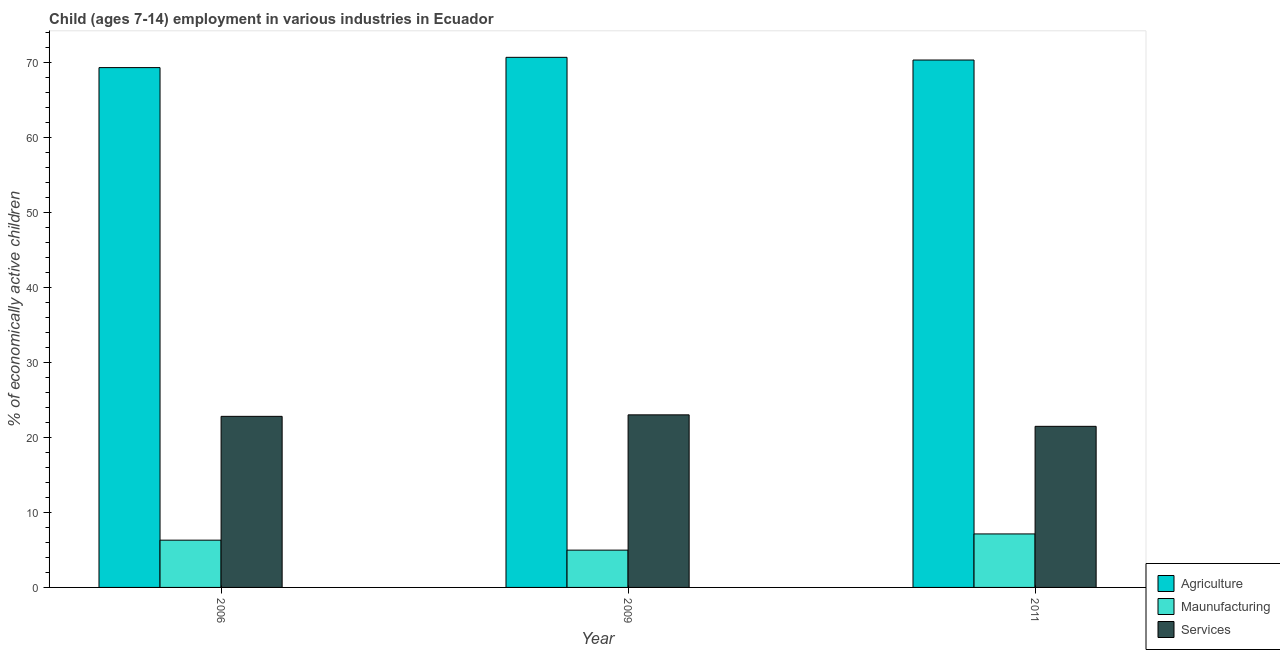How many different coloured bars are there?
Offer a very short reply. 3. Are the number of bars per tick equal to the number of legend labels?
Your answer should be compact. Yes. Are the number of bars on each tick of the X-axis equal?
Provide a succinct answer. Yes. How many bars are there on the 2nd tick from the left?
Your answer should be very brief. 3. In how many cases, is the number of bars for a given year not equal to the number of legend labels?
Your response must be concise. 0. Across all years, what is the maximum percentage of economically active children in agriculture?
Ensure brevity in your answer.  70.65. Across all years, what is the minimum percentage of economically active children in manufacturing?
Ensure brevity in your answer.  4.97. What is the total percentage of economically active children in agriculture in the graph?
Your response must be concise. 210.22. What is the difference between the percentage of economically active children in services in 2006 and that in 2011?
Your answer should be compact. 1.33. What is the difference between the percentage of economically active children in agriculture in 2011 and the percentage of economically active children in manufacturing in 2009?
Your answer should be very brief. -0.36. What is the average percentage of economically active children in agriculture per year?
Ensure brevity in your answer.  70.07. In the year 2011, what is the difference between the percentage of economically active children in agriculture and percentage of economically active children in services?
Keep it short and to the point. 0. What is the ratio of the percentage of economically active children in agriculture in 2006 to that in 2009?
Your answer should be compact. 0.98. What is the difference between the highest and the second highest percentage of economically active children in agriculture?
Your answer should be compact. 0.36. What is the difference between the highest and the lowest percentage of economically active children in agriculture?
Make the answer very short. 1.37. What does the 3rd bar from the left in 2006 represents?
Offer a terse response. Services. What does the 2nd bar from the right in 2011 represents?
Make the answer very short. Maunufacturing. Does the graph contain grids?
Keep it short and to the point. No. How are the legend labels stacked?
Offer a very short reply. Vertical. What is the title of the graph?
Offer a very short reply. Child (ages 7-14) employment in various industries in Ecuador. Does "Domestic" appear as one of the legend labels in the graph?
Your answer should be very brief. No. What is the label or title of the Y-axis?
Ensure brevity in your answer.  % of economically active children. What is the % of economically active children of Agriculture in 2006?
Your response must be concise. 69.28. What is the % of economically active children of Services in 2006?
Provide a short and direct response. 22.8. What is the % of economically active children in Agriculture in 2009?
Offer a terse response. 70.65. What is the % of economically active children of Maunufacturing in 2009?
Keep it short and to the point. 4.97. What is the % of economically active children in Agriculture in 2011?
Offer a very short reply. 70.29. What is the % of economically active children of Maunufacturing in 2011?
Your answer should be compact. 7.13. What is the % of economically active children of Services in 2011?
Your answer should be very brief. 21.47. Across all years, what is the maximum % of economically active children in Agriculture?
Your response must be concise. 70.65. Across all years, what is the maximum % of economically active children in Maunufacturing?
Offer a very short reply. 7.13. Across all years, what is the maximum % of economically active children in Services?
Provide a short and direct response. 23. Across all years, what is the minimum % of economically active children of Agriculture?
Offer a terse response. 69.28. Across all years, what is the minimum % of economically active children of Maunufacturing?
Your answer should be compact. 4.97. Across all years, what is the minimum % of economically active children of Services?
Offer a very short reply. 21.47. What is the total % of economically active children in Agriculture in the graph?
Your answer should be compact. 210.22. What is the total % of economically active children of Services in the graph?
Offer a very short reply. 67.27. What is the difference between the % of economically active children of Agriculture in 2006 and that in 2009?
Offer a very short reply. -1.37. What is the difference between the % of economically active children in Maunufacturing in 2006 and that in 2009?
Your answer should be very brief. 1.33. What is the difference between the % of economically active children in Agriculture in 2006 and that in 2011?
Provide a succinct answer. -1.01. What is the difference between the % of economically active children in Maunufacturing in 2006 and that in 2011?
Make the answer very short. -0.83. What is the difference between the % of economically active children in Services in 2006 and that in 2011?
Provide a succinct answer. 1.33. What is the difference between the % of economically active children of Agriculture in 2009 and that in 2011?
Provide a succinct answer. 0.36. What is the difference between the % of economically active children of Maunufacturing in 2009 and that in 2011?
Your answer should be very brief. -2.16. What is the difference between the % of economically active children in Services in 2009 and that in 2011?
Your response must be concise. 1.53. What is the difference between the % of economically active children in Agriculture in 2006 and the % of economically active children in Maunufacturing in 2009?
Provide a short and direct response. 64.31. What is the difference between the % of economically active children in Agriculture in 2006 and the % of economically active children in Services in 2009?
Ensure brevity in your answer.  46.28. What is the difference between the % of economically active children in Maunufacturing in 2006 and the % of economically active children in Services in 2009?
Provide a short and direct response. -16.7. What is the difference between the % of economically active children of Agriculture in 2006 and the % of economically active children of Maunufacturing in 2011?
Offer a terse response. 62.15. What is the difference between the % of economically active children of Agriculture in 2006 and the % of economically active children of Services in 2011?
Provide a succinct answer. 47.81. What is the difference between the % of economically active children of Maunufacturing in 2006 and the % of economically active children of Services in 2011?
Your answer should be very brief. -15.17. What is the difference between the % of economically active children in Agriculture in 2009 and the % of economically active children in Maunufacturing in 2011?
Keep it short and to the point. 63.52. What is the difference between the % of economically active children in Agriculture in 2009 and the % of economically active children in Services in 2011?
Your response must be concise. 49.18. What is the difference between the % of economically active children in Maunufacturing in 2009 and the % of economically active children in Services in 2011?
Offer a terse response. -16.5. What is the average % of economically active children of Agriculture per year?
Give a very brief answer. 70.07. What is the average % of economically active children of Maunufacturing per year?
Your response must be concise. 6.13. What is the average % of economically active children of Services per year?
Offer a terse response. 22.42. In the year 2006, what is the difference between the % of economically active children of Agriculture and % of economically active children of Maunufacturing?
Provide a short and direct response. 62.98. In the year 2006, what is the difference between the % of economically active children in Agriculture and % of economically active children in Services?
Keep it short and to the point. 46.48. In the year 2006, what is the difference between the % of economically active children in Maunufacturing and % of economically active children in Services?
Provide a succinct answer. -16.5. In the year 2009, what is the difference between the % of economically active children in Agriculture and % of economically active children in Maunufacturing?
Provide a short and direct response. 65.68. In the year 2009, what is the difference between the % of economically active children of Agriculture and % of economically active children of Services?
Offer a very short reply. 47.65. In the year 2009, what is the difference between the % of economically active children of Maunufacturing and % of economically active children of Services?
Offer a very short reply. -18.03. In the year 2011, what is the difference between the % of economically active children of Agriculture and % of economically active children of Maunufacturing?
Provide a succinct answer. 63.16. In the year 2011, what is the difference between the % of economically active children in Agriculture and % of economically active children in Services?
Your answer should be compact. 48.82. In the year 2011, what is the difference between the % of economically active children in Maunufacturing and % of economically active children in Services?
Make the answer very short. -14.34. What is the ratio of the % of economically active children in Agriculture in 2006 to that in 2009?
Your answer should be compact. 0.98. What is the ratio of the % of economically active children of Maunufacturing in 2006 to that in 2009?
Your answer should be very brief. 1.27. What is the ratio of the % of economically active children of Agriculture in 2006 to that in 2011?
Offer a very short reply. 0.99. What is the ratio of the % of economically active children in Maunufacturing in 2006 to that in 2011?
Your answer should be very brief. 0.88. What is the ratio of the % of economically active children of Services in 2006 to that in 2011?
Provide a succinct answer. 1.06. What is the ratio of the % of economically active children in Agriculture in 2009 to that in 2011?
Offer a very short reply. 1.01. What is the ratio of the % of economically active children in Maunufacturing in 2009 to that in 2011?
Ensure brevity in your answer.  0.7. What is the ratio of the % of economically active children in Services in 2009 to that in 2011?
Your answer should be very brief. 1.07. What is the difference between the highest and the second highest % of economically active children in Agriculture?
Keep it short and to the point. 0.36. What is the difference between the highest and the second highest % of economically active children in Maunufacturing?
Provide a succinct answer. 0.83. What is the difference between the highest and the second highest % of economically active children in Services?
Your response must be concise. 0.2. What is the difference between the highest and the lowest % of economically active children in Agriculture?
Your answer should be very brief. 1.37. What is the difference between the highest and the lowest % of economically active children of Maunufacturing?
Your response must be concise. 2.16. What is the difference between the highest and the lowest % of economically active children of Services?
Keep it short and to the point. 1.53. 